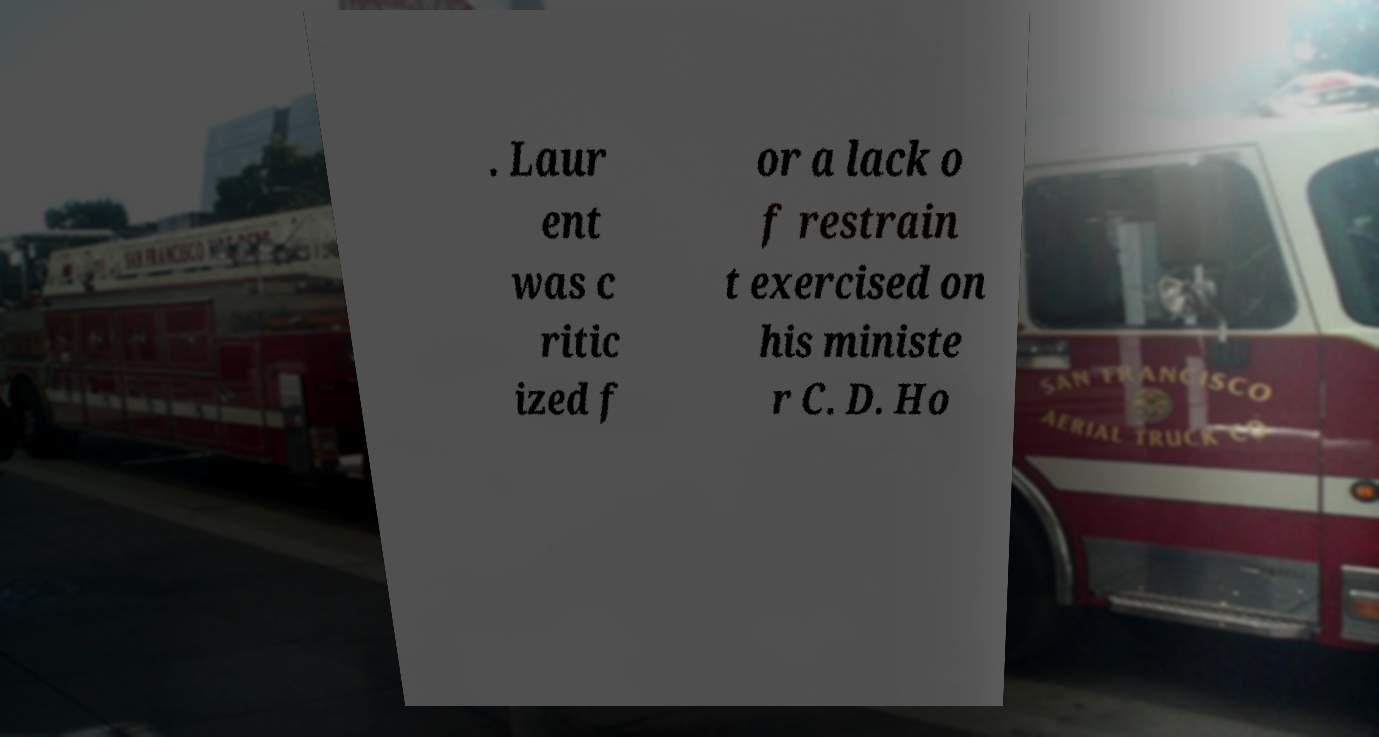Please identify and transcribe the text found in this image. . Laur ent was c ritic ized f or a lack o f restrain t exercised on his ministe r C. D. Ho 